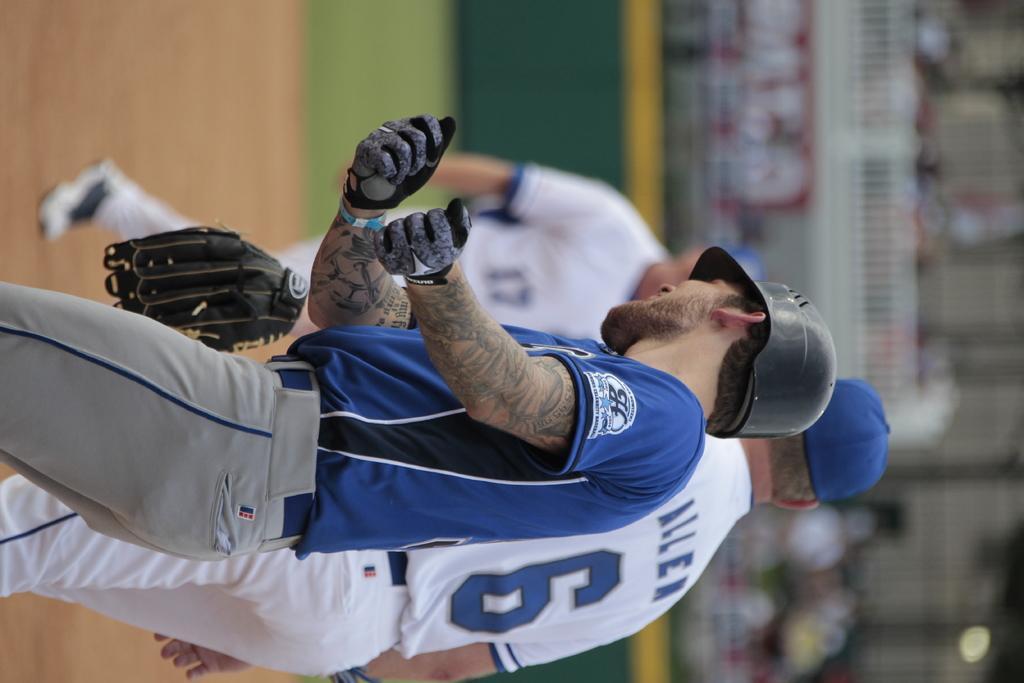Could you give a brief overview of what you see in this image? In this image, there are three people standing. This man wore a glove. The background looks blurry. 